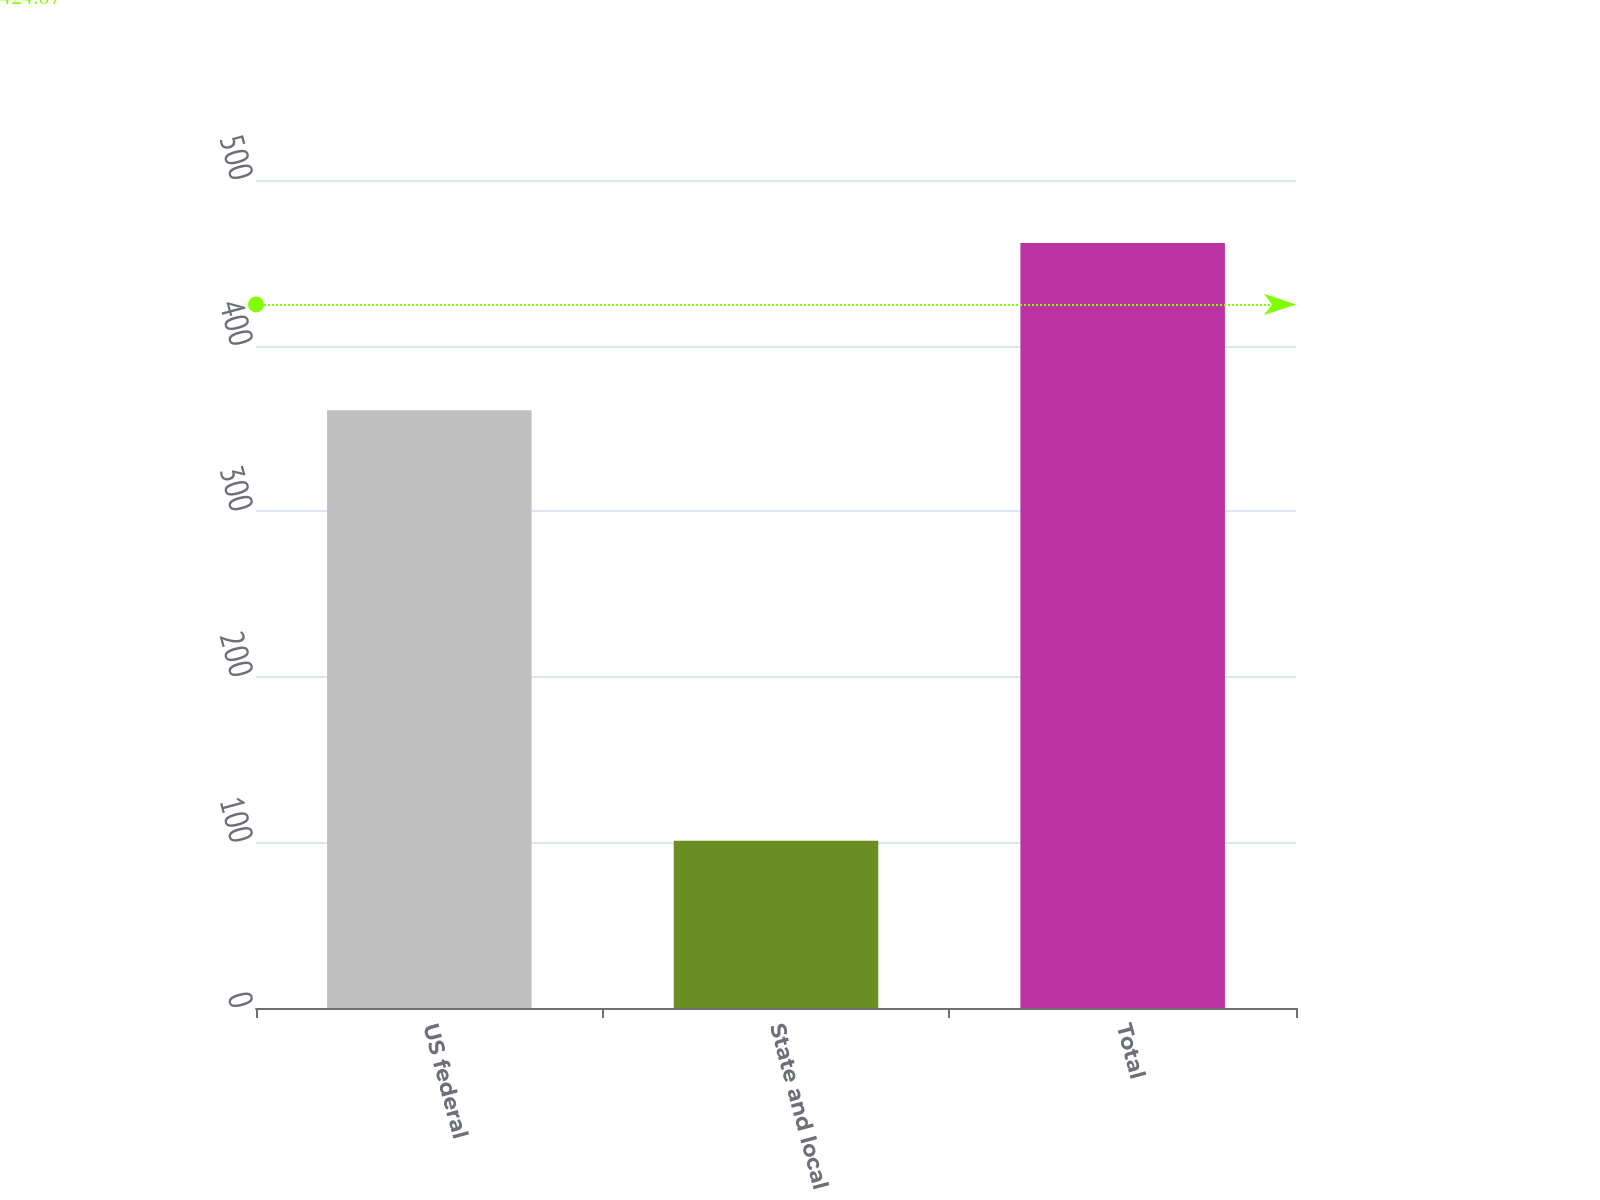Convert chart. <chart><loc_0><loc_0><loc_500><loc_500><bar_chart><fcel>US federal<fcel>State and local<fcel>Total<nl><fcel>361<fcel>101<fcel>462<nl></chart> 